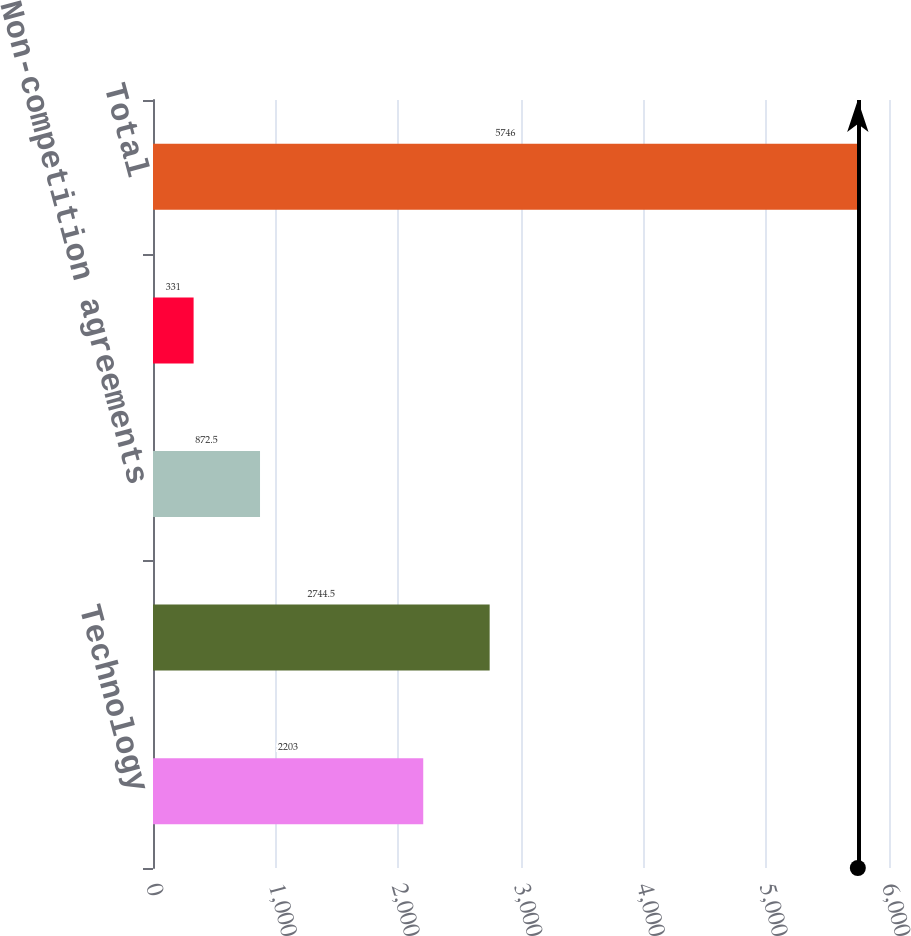Convert chart. <chart><loc_0><loc_0><loc_500><loc_500><bar_chart><fcel>Technology<fcel>Customer relationships<fcel>Non-competition agreements<fcel>Tradenames<fcel>Total<nl><fcel>2203<fcel>2744.5<fcel>872.5<fcel>331<fcel>5746<nl></chart> 